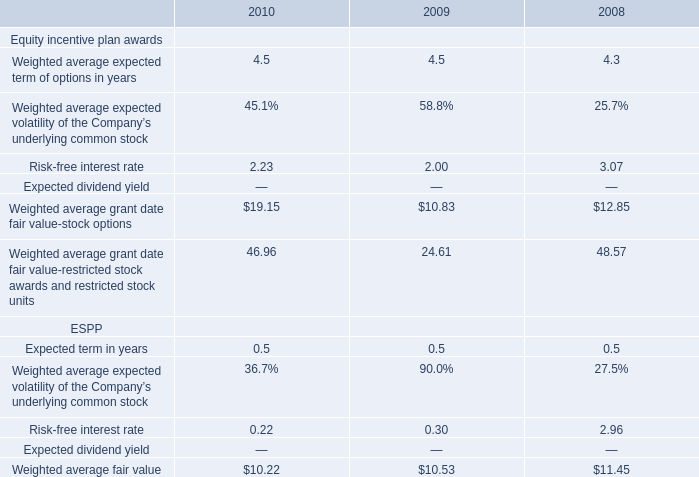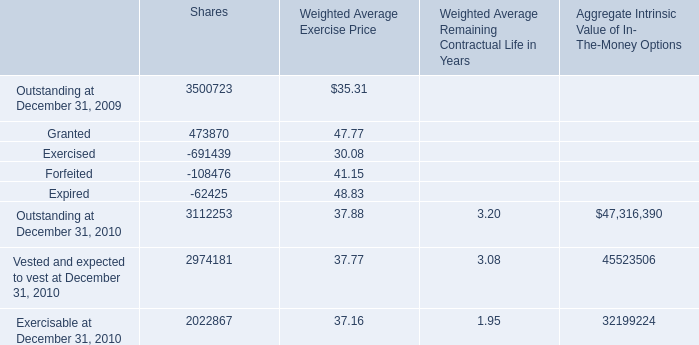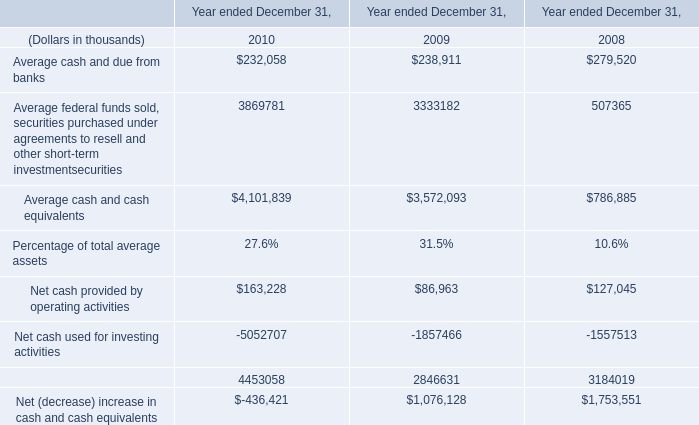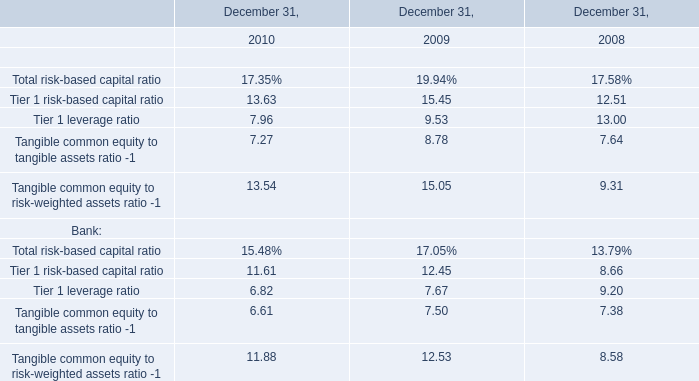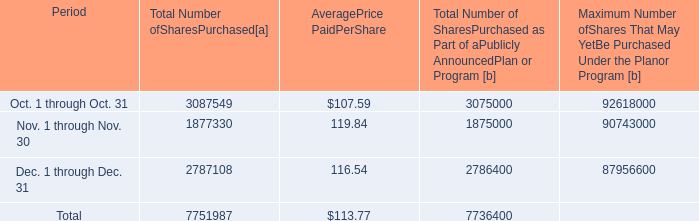What is the average amount of Exercisable at December 31, 2010 of Shares, and Oct. 1 through Oct. 31 of [EMPTY].1 ? 
Computations: ((2022867.0 + 3087549.0) / 2)
Answer: 2555208.0. 